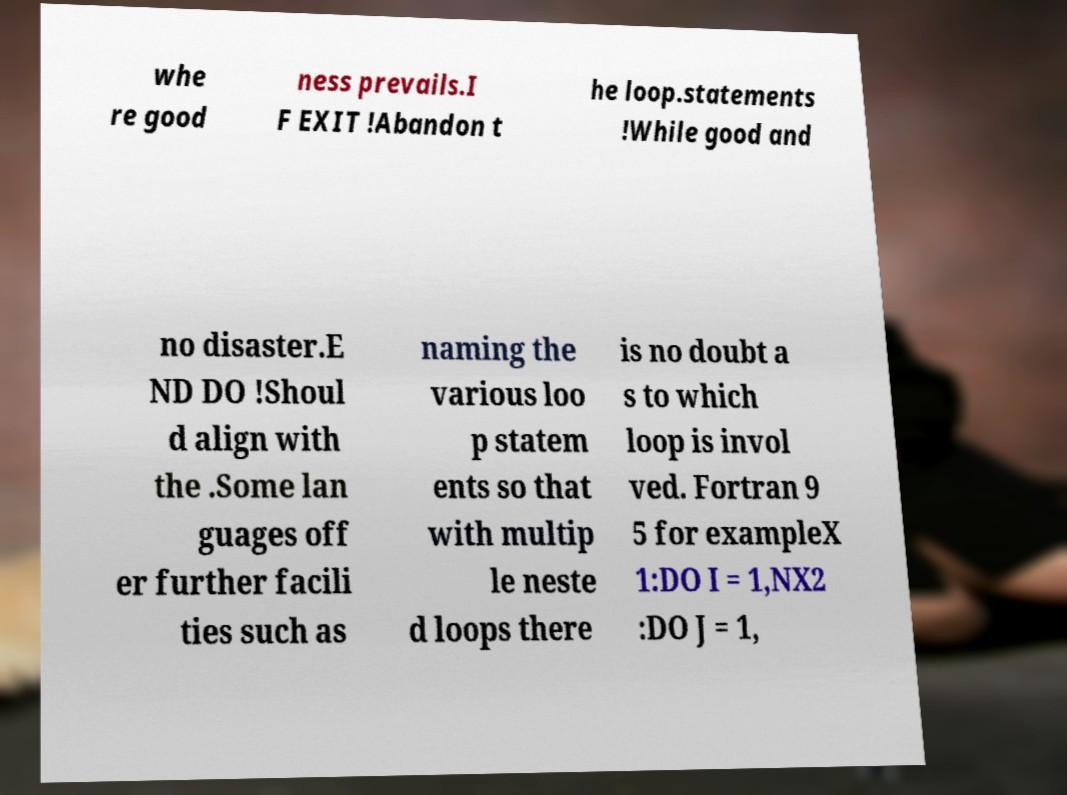Could you extract and type out the text from this image? whe re good ness prevails.I F EXIT !Abandon t he loop.statements !While good and no disaster.E ND DO !Shoul d align with the .Some lan guages off er further facili ties such as naming the various loo p statem ents so that with multip le neste d loops there is no doubt a s to which loop is invol ved. Fortran 9 5 for exampleX 1:DO I = 1,NX2 :DO J = 1, 